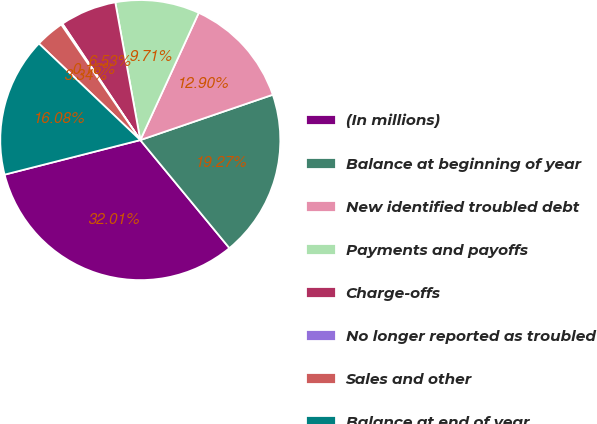<chart> <loc_0><loc_0><loc_500><loc_500><pie_chart><fcel>(In millions)<fcel>Balance at beginning of year<fcel>New identified troubled debt<fcel>Payments and payoffs<fcel>Charge-offs<fcel>No longer reported as troubled<fcel>Sales and other<fcel>Balance at end of year<nl><fcel>32.01%<fcel>19.27%<fcel>12.9%<fcel>9.71%<fcel>6.53%<fcel>0.16%<fcel>3.34%<fcel>16.08%<nl></chart> 